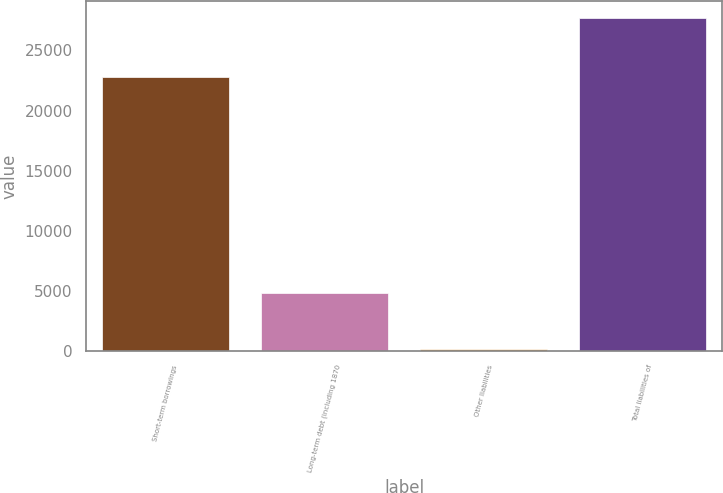Convert chart to OTSL. <chart><loc_0><loc_0><loc_500><loc_500><bar_chart><fcel>Short-term borrowings<fcel>Long-term debt (including 1870<fcel>Other liabilities<fcel>Total liabilities of<nl><fcel>22753<fcel>4822<fcel>146<fcel>27721<nl></chart> 